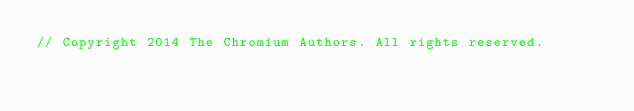Convert code to text. <code><loc_0><loc_0><loc_500><loc_500><_C_>// Copyright 2014 The Chromium Authors. All rights reserved.</code> 